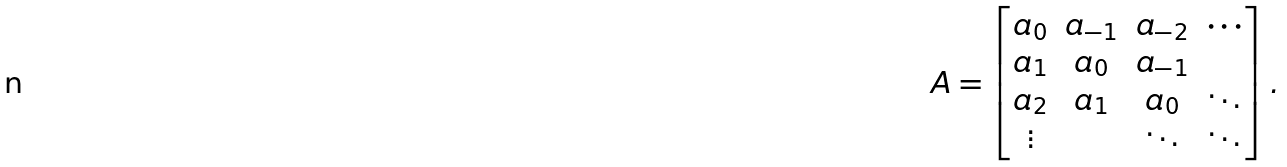<formula> <loc_0><loc_0><loc_500><loc_500>A = \begin{bmatrix} a _ { 0 } & a _ { - 1 } & a _ { - 2 } & \cdots \\ a _ { 1 } & a _ { 0 } & a _ { - 1 } & \\ a _ { 2 } & a _ { 1 } & a _ { 0 } & \ddots \\ \vdots & & \ddots & \ddots \end{bmatrix} .</formula> 